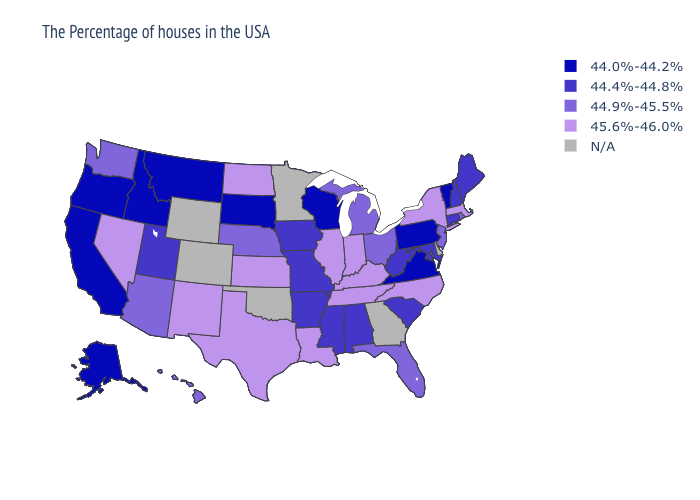Among the states that border Maryland , which have the highest value?
Be succinct. West Virginia. What is the lowest value in the USA?
Write a very short answer. 44.0%-44.2%. Which states have the lowest value in the USA?
Concise answer only. Vermont, Pennsylvania, Virginia, Wisconsin, South Dakota, Montana, Idaho, California, Oregon, Alaska. What is the lowest value in the Northeast?
Concise answer only. 44.0%-44.2%. Name the states that have a value in the range 45.6%-46.0%?
Quick response, please. Massachusetts, New York, North Carolina, Kentucky, Indiana, Tennessee, Illinois, Louisiana, Kansas, Texas, North Dakota, New Mexico, Nevada. Does the map have missing data?
Short answer required. Yes. Which states hav the highest value in the Northeast?
Answer briefly. Massachusetts, New York. What is the highest value in the USA?
Keep it brief. 45.6%-46.0%. Does Kentucky have the highest value in the South?
Answer briefly. Yes. Does California have the lowest value in the USA?
Be succinct. Yes. What is the highest value in the MidWest ?
Concise answer only. 45.6%-46.0%. What is the value of Maine?
Concise answer only. 44.4%-44.8%. What is the value of Nebraska?
Short answer required. 44.9%-45.5%. How many symbols are there in the legend?
Give a very brief answer. 5. 